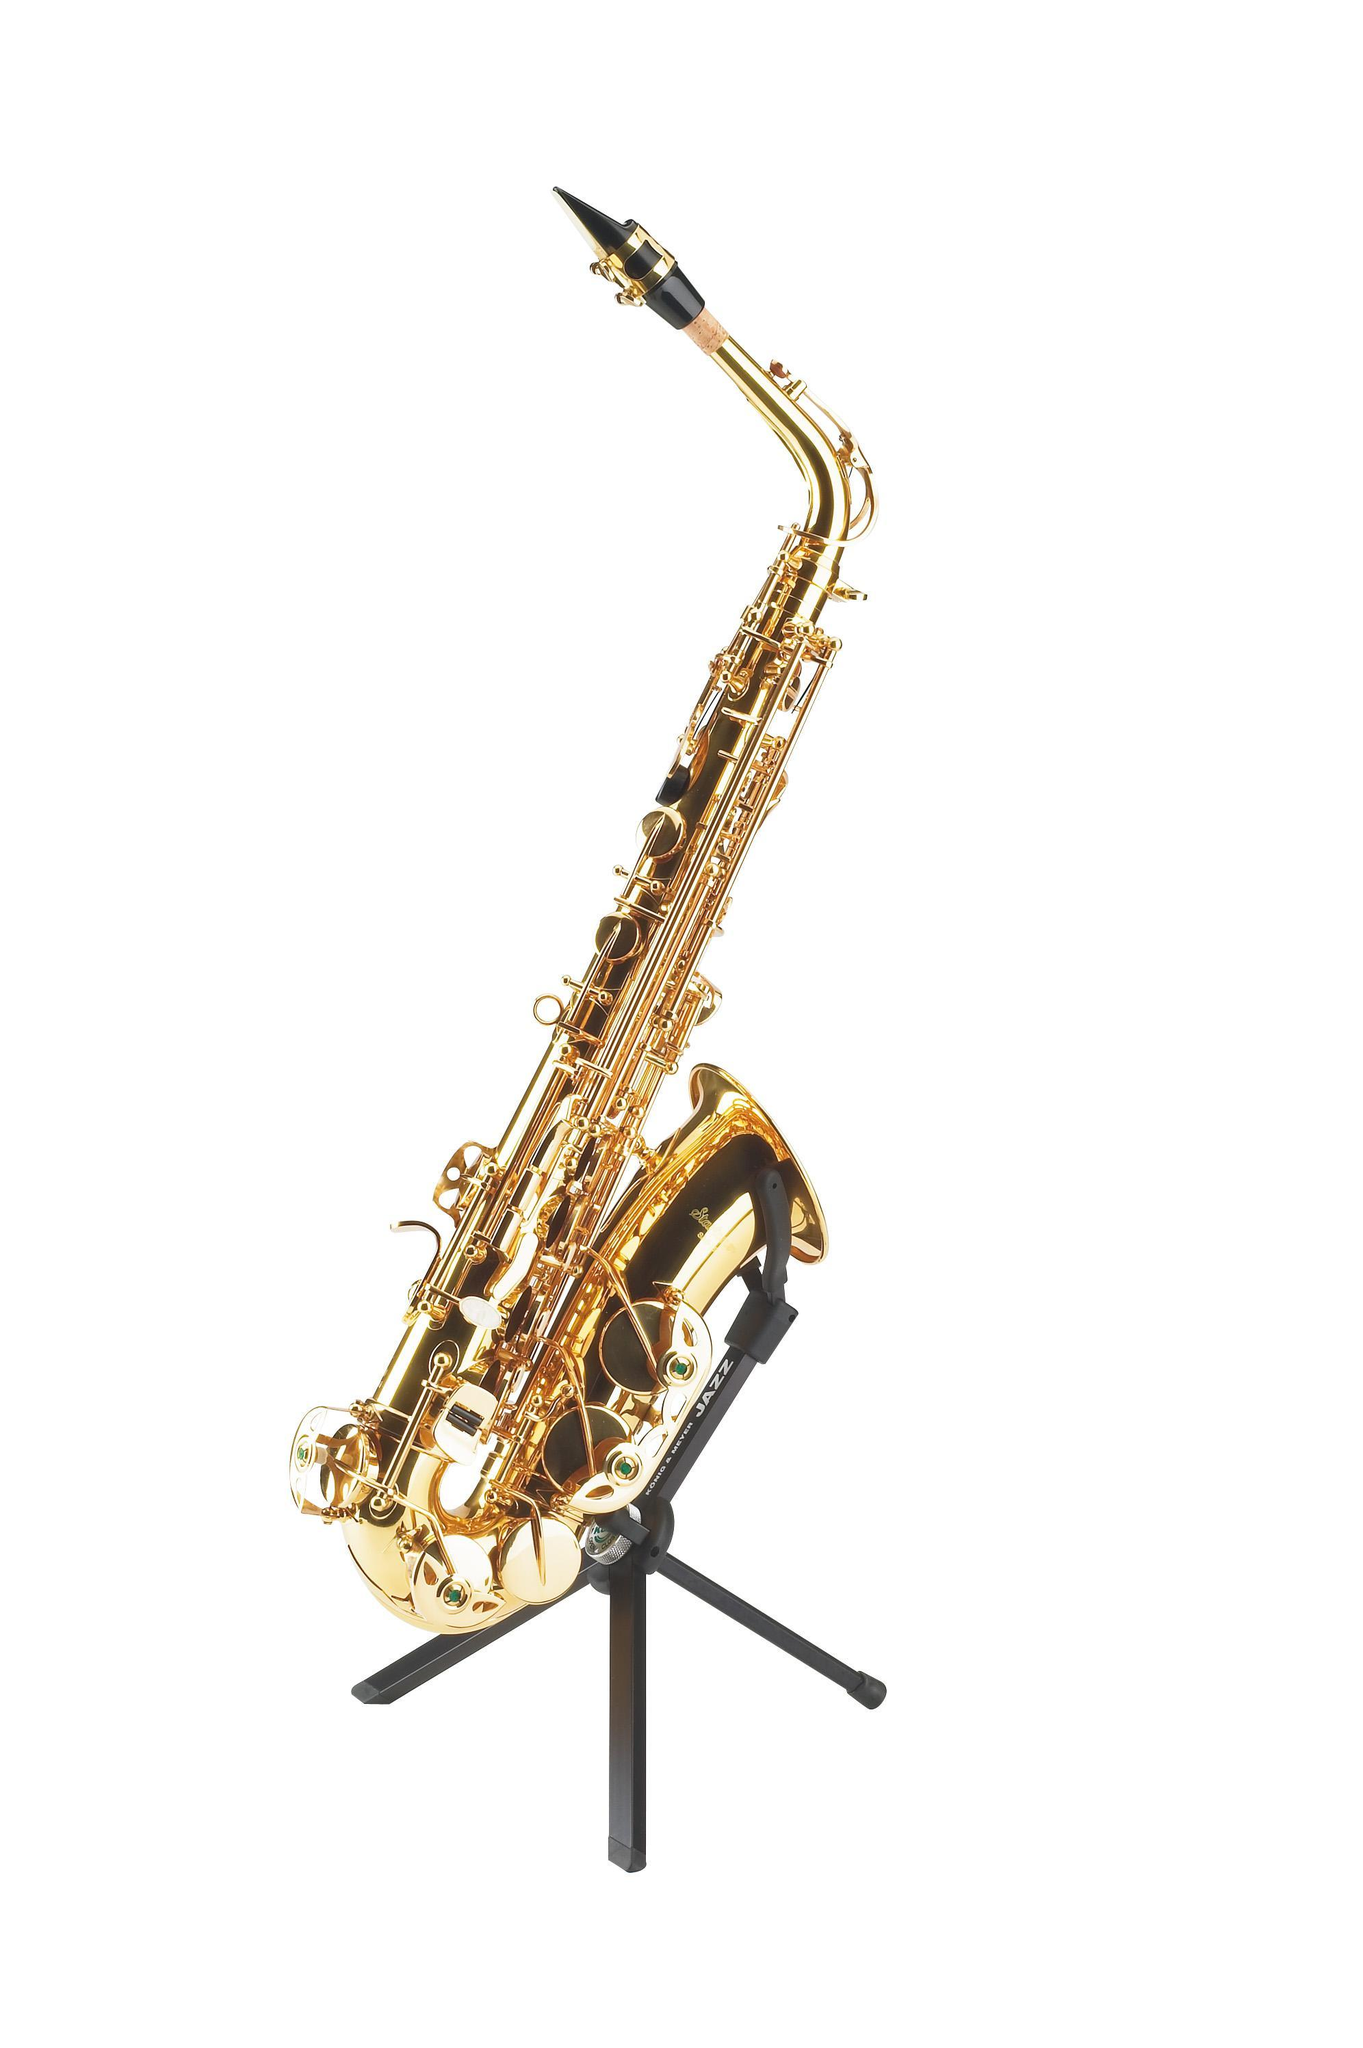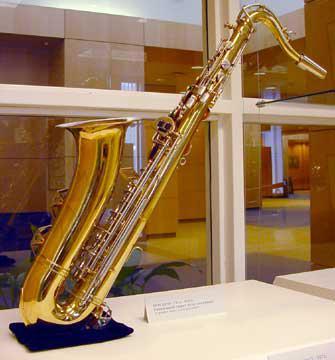The first image is the image on the left, the second image is the image on the right. Considering the images on both sides, is "The left and right image contains the same number of saxophones being held by their stand alone." valid? Answer yes or no. Yes. The first image is the image on the left, the second image is the image on the right. Given the left and right images, does the statement "The trombone is facing to the right in the right image." hold true? Answer yes or no. No. 